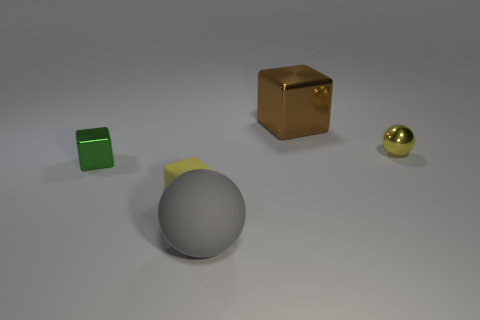Are there an equal number of yellow metal balls to the left of the yellow cube and yellow objects that are on the left side of the brown thing?
Give a very brief answer. No. The tiny thing that is the same material as the big sphere is what color?
Ensure brevity in your answer.  Yellow. What number of other cubes are made of the same material as the green cube?
Keep it short and to the point. 1. Do the metallic block to the left of the small yellow cube and the large metallic object have the same color?
Give a very brief answer. No. How many yellow metallic objects have the same shape as the large matte thing?
Keep it short and to the point. 1. Are there an equal number of small metallic cubes that are to the left of the tiny green shiny block and small purple metallic balls?
Give a very brief answer. Yes. What color is the shiny cube that is the same size as the metallic ball?
Keep it short and to the point. Green. Are there any large objects of the same shape as the tiny rubber thing?
Your answer should be very brief. Yes. There is a cube that is in front of the shiny cube that is left of the brown metallic block on the right side of the tiny metal block; what is its material?
Ensure brevity in your answer.  Rubber. What number of other objects are the same size as the yellow sphere?
Provide a succinct answer. 2. 